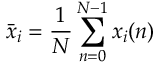<formula> <loc_0><loc_0><loc_500><loc_500>\bar { x } _ { i } = \frac { 1 } { N } \sum _ { n = 0 } ^ { N - 1 } x _ { i } ( n )</formula> 